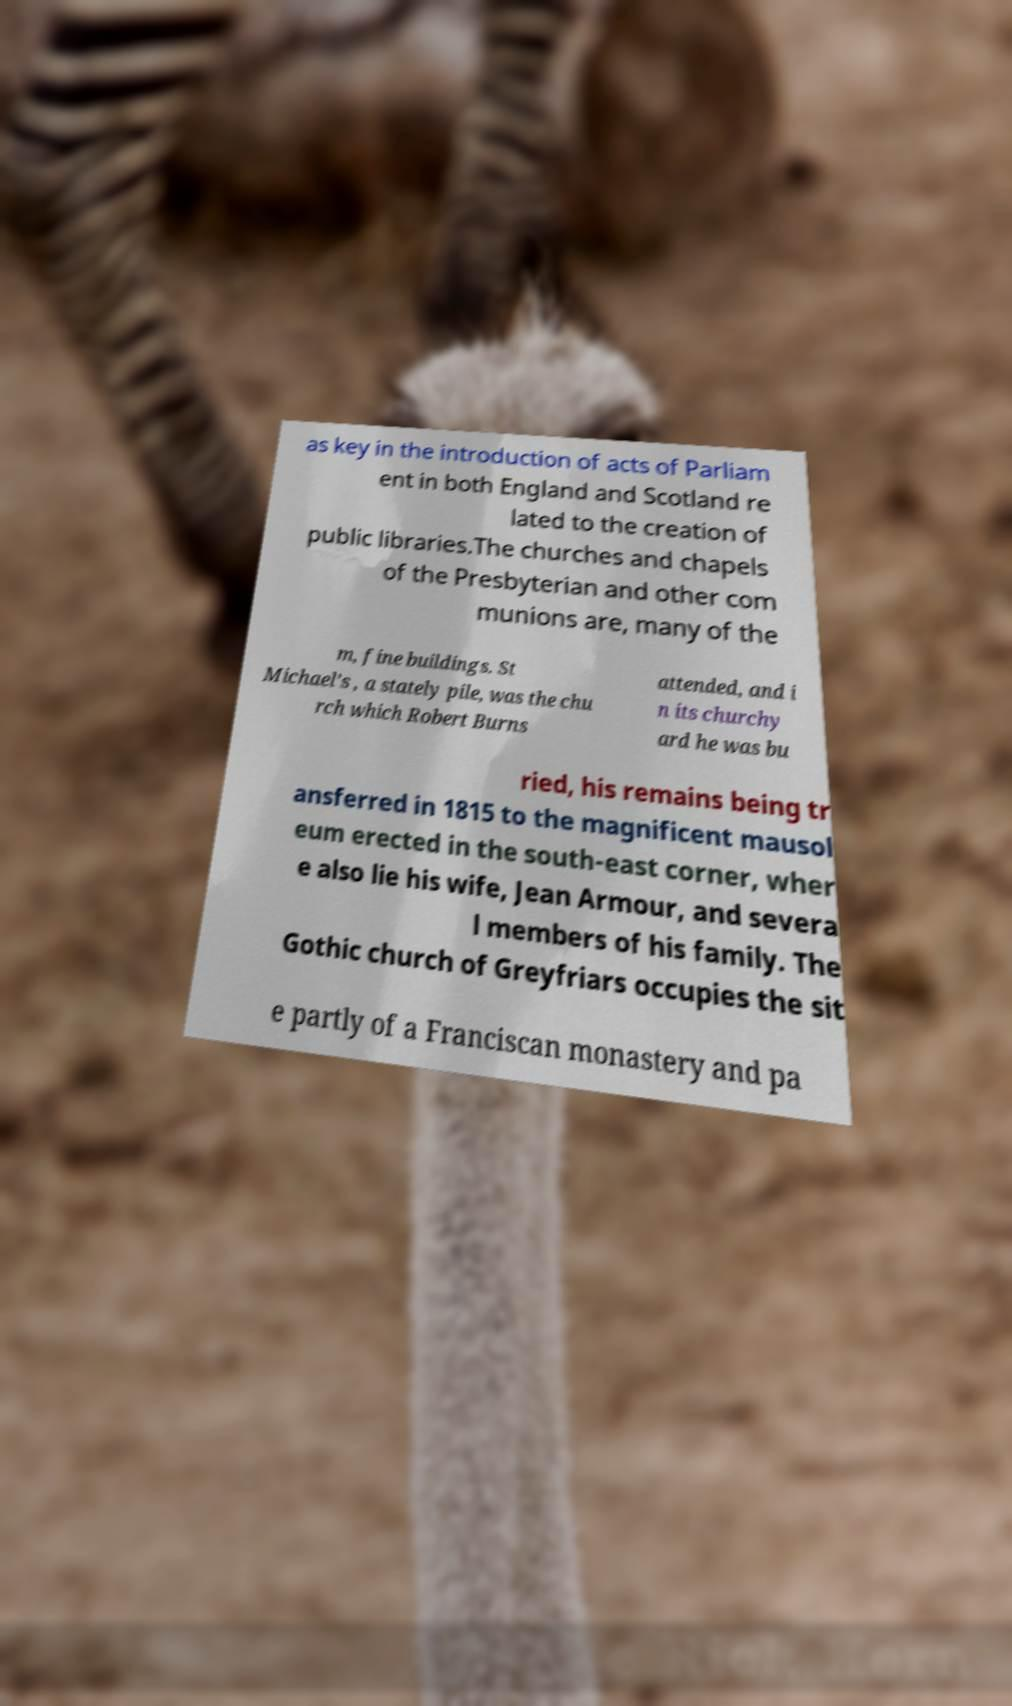What messages or text are displayed in this image? I need them in a readable, typed format. as key in the introduction of acts of Parliam ent in both England and Scotland re lated to the creation of public libraries.The churches and chapels of the Presbyterian and other com munions are, many of the m, fine buildings. St Michael’s , a stately pile, was the chu rch which Robert Burns attended, and i n its churchy ard he was bu ried, his remains being tr ansferred in 1815 to the magnificent mausol eum erected in the south-east corner, wher e also lie his wife, Jean Armour, and severa l members of his family. The Gothic church of Greyfriars occupies the sit e partly of a Franciscan monastery and pa 